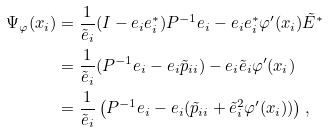Convert formula to latex. <formula><loc_0><loc_0><loc_500><loc_500>\Psi _ { \varphi } ( x _ { i } ) & = \frac { 1 } { \tilde { e } _ { i } } ( I - { e } _ { i } { e } _ { i } ^ { * } ) P ^ { - 1 } { e } _ { i } - { e } _ { i } { e } _ { i } ^ { * } \varphi ^ { \prime } ( x _ { i } ) \tilde { E } ^ { * } \\ & = \frac { 1 } { \tilde { e } _ { i } } ( P ^ { - 1 } { e } _ { i } - { e } _ { i } \tilde { p } _ { i i } ) - { e } _ { i } \tilde { e } _ { i } \varphi ^ { \prime } ( x _ { i } ) \\ & = \frac { 1 } { \tilde { e } _ { i } } \left ( P ^ { - 1 } { e } _ { i } - { e } _ { i } ( \tilde { p } _ { i i } + \tilde { e } _ { i } ^ { 2 } \varphi ^ { \prime } ( x _ { i } ) ) \right ) ,</formula> 